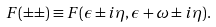<formula> <loc_0><loc_0><loc_500><loc_500>F ( \pm \pm ) \equiv F ( \epsilon \pm i \eta , \epsilon + \omega \pm i \eta ) .</formula> 